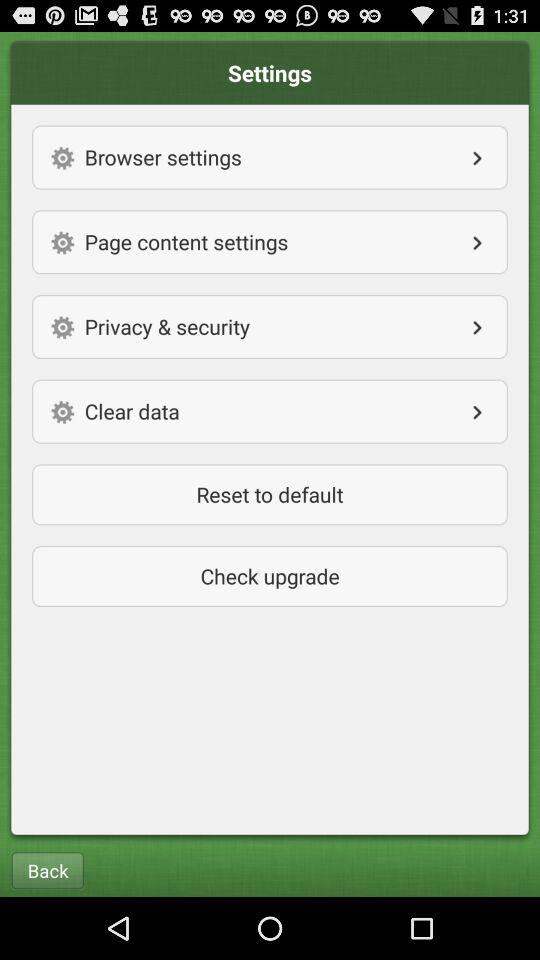How many settings sections are there in the settings menu?
Answer the question using a single word or phrase. 4 